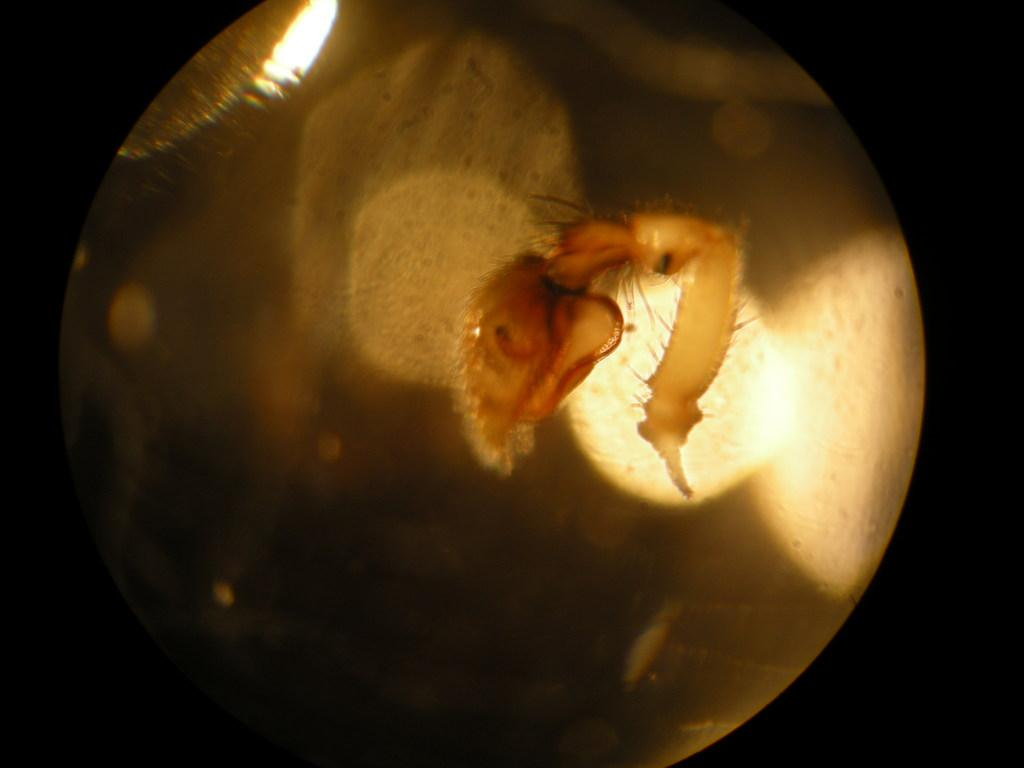What is located in the foreground of the image? There is an insect in the foreground of the image. What can be seen in the background of the image? There is light visible in the background of the image. What type of beds can be seen in the image? There are no beds present in the image; it features an insect in the foreground and light in the background. What subject is the insect teaching in the image? There is no indication in the image that the insect is teaching any subject. 